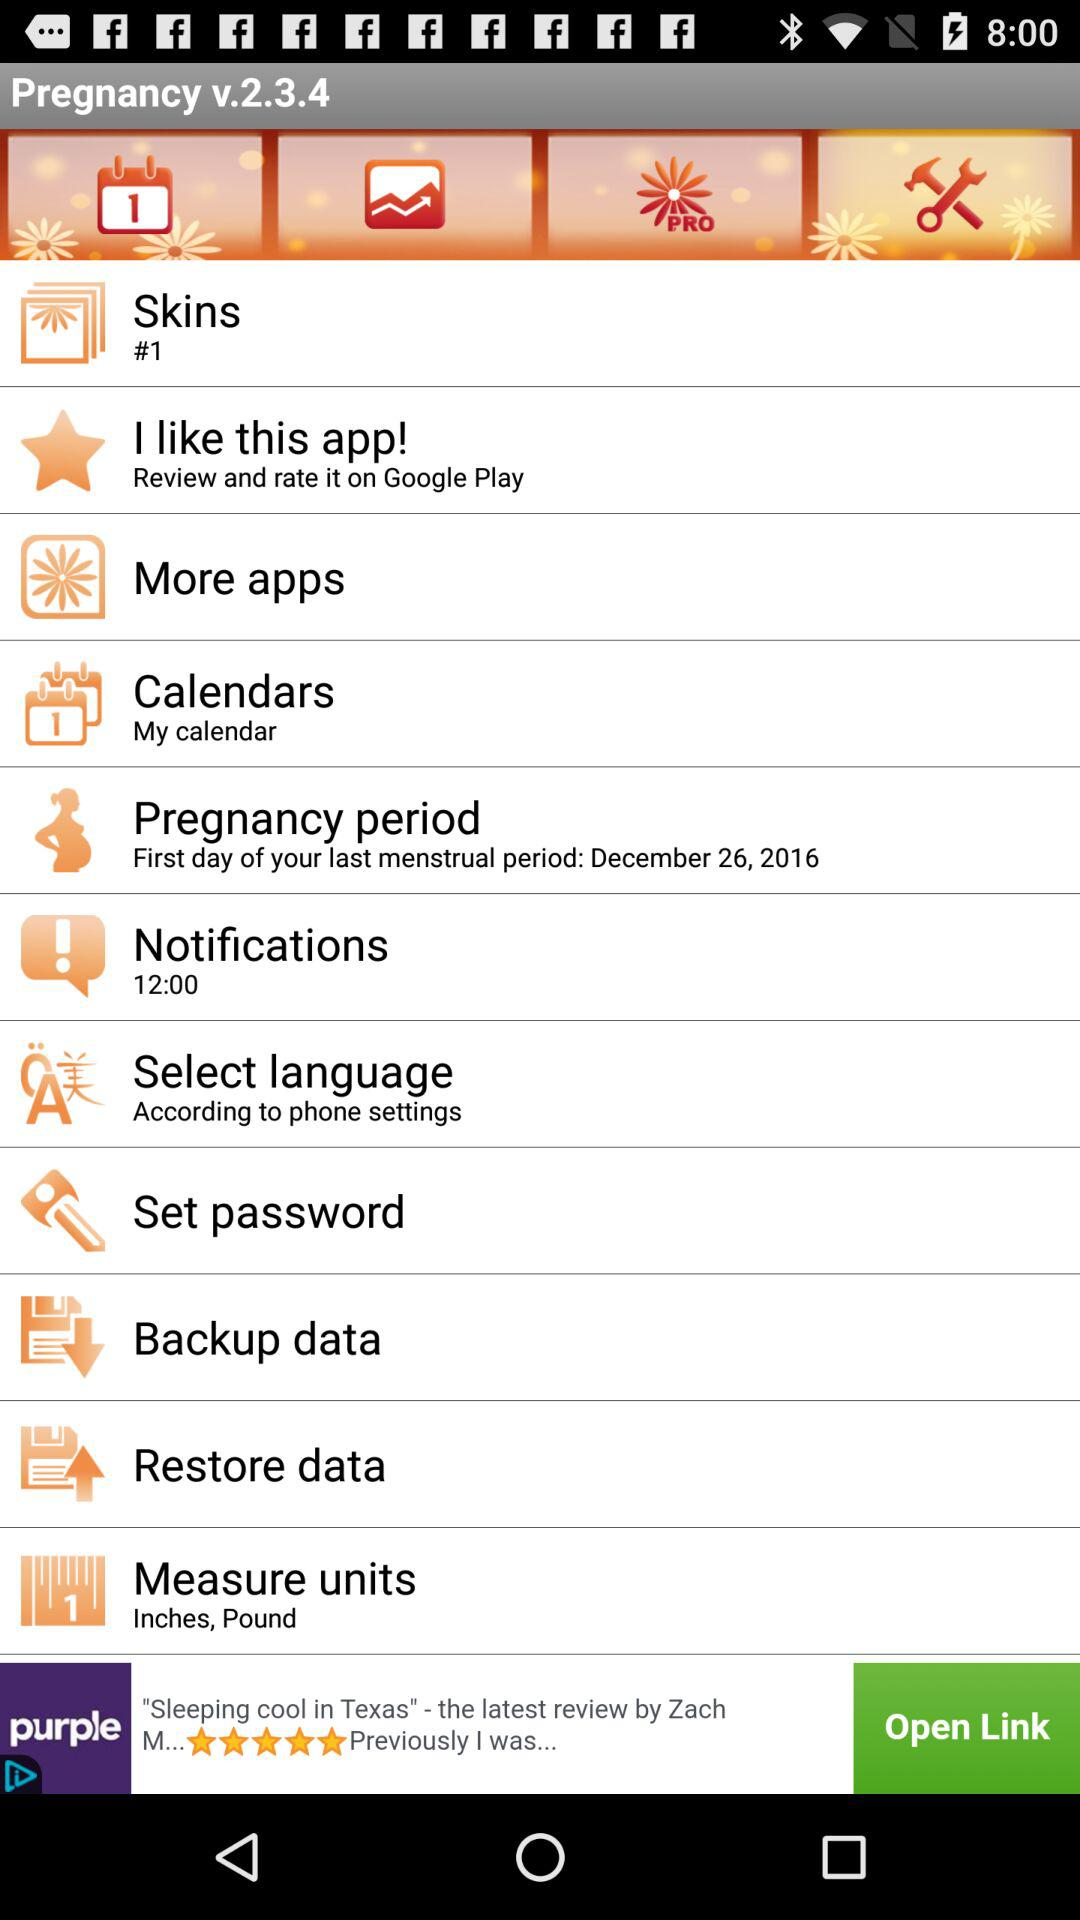Which tab has been chosen?
When the provided information is insufficient, respond with <no answer>. <no answer> 